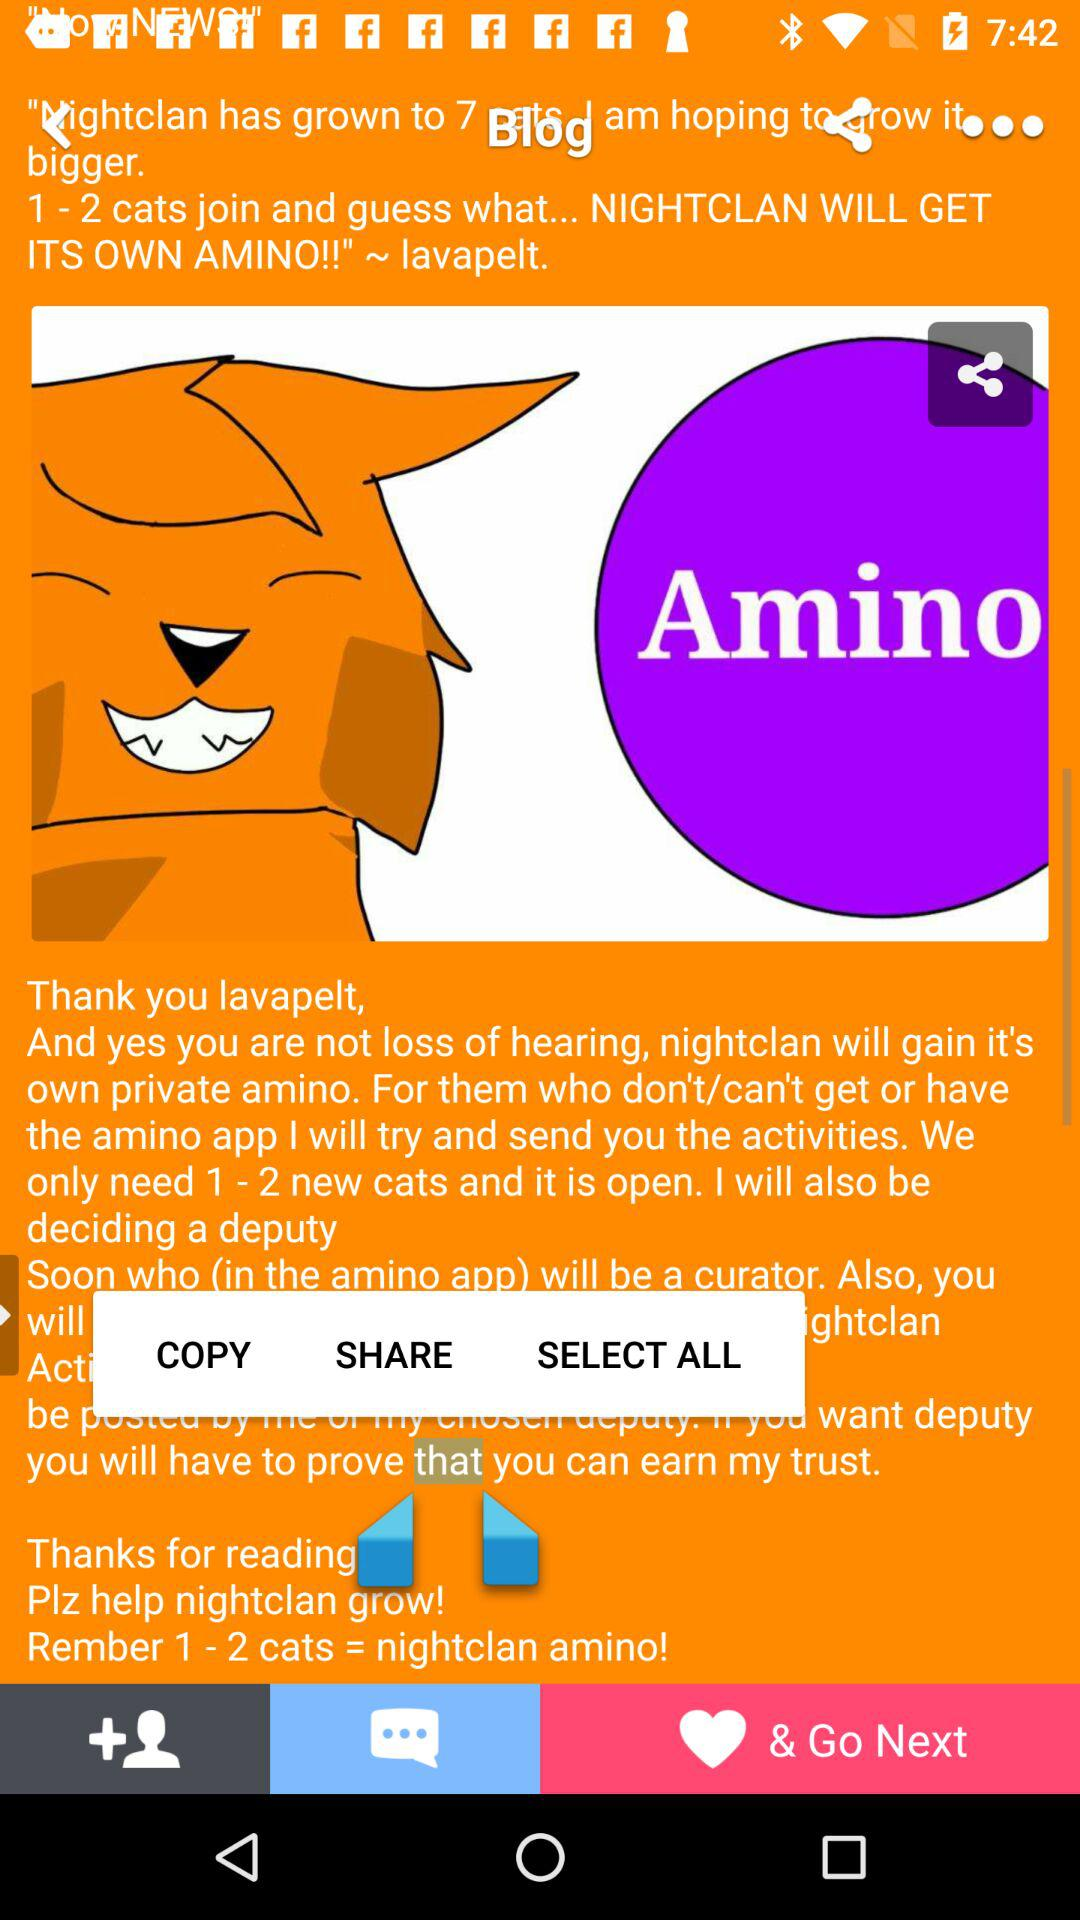How many more cats does Nightclan need to join in order to gain its own Amino?
Answer the question using a single word or phrase. 1 - 2 